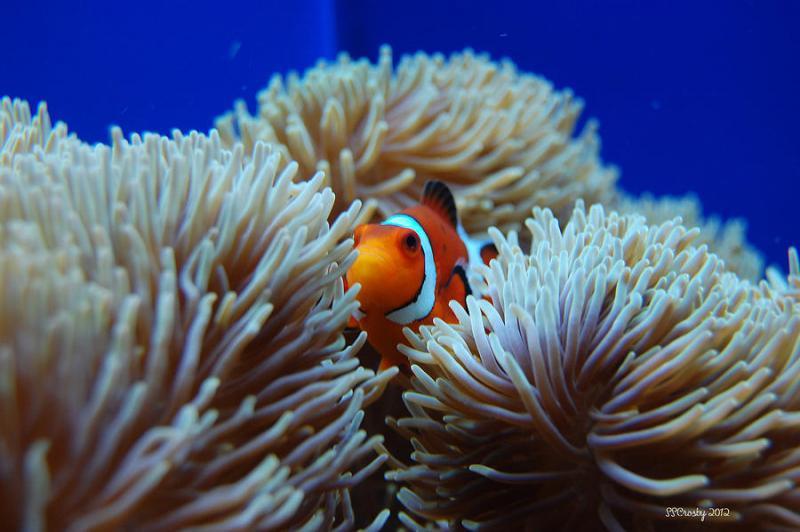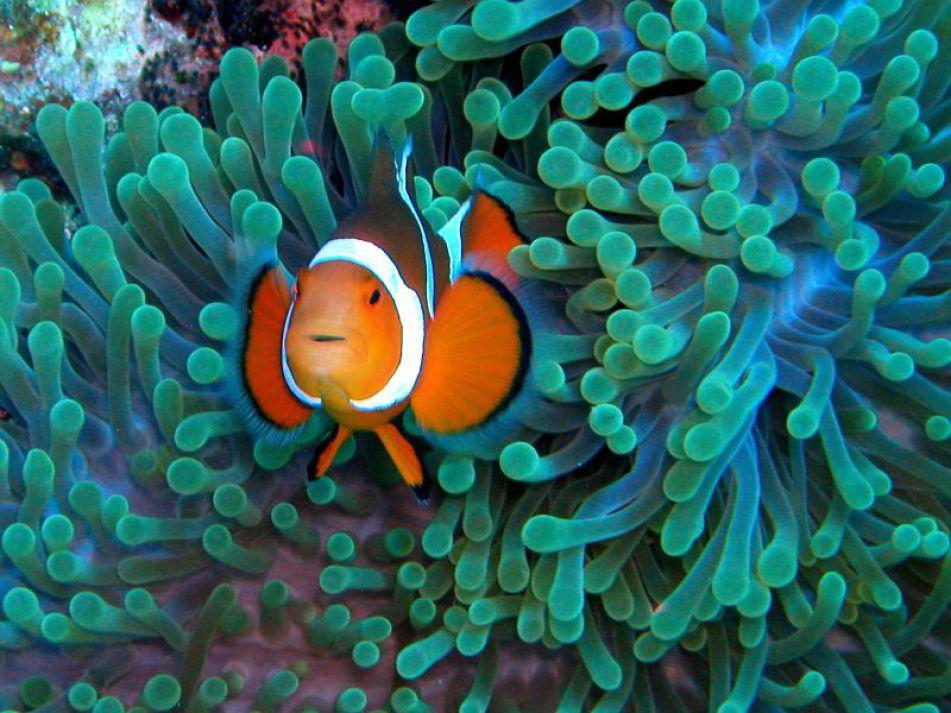The first image is the image on the left, the second image is the image on the right. Assess this claim about the two images: "At least one image shows a striped clown fish swimming among anemone tendrils.". Correct or not? Answer yes or no. Yes. 